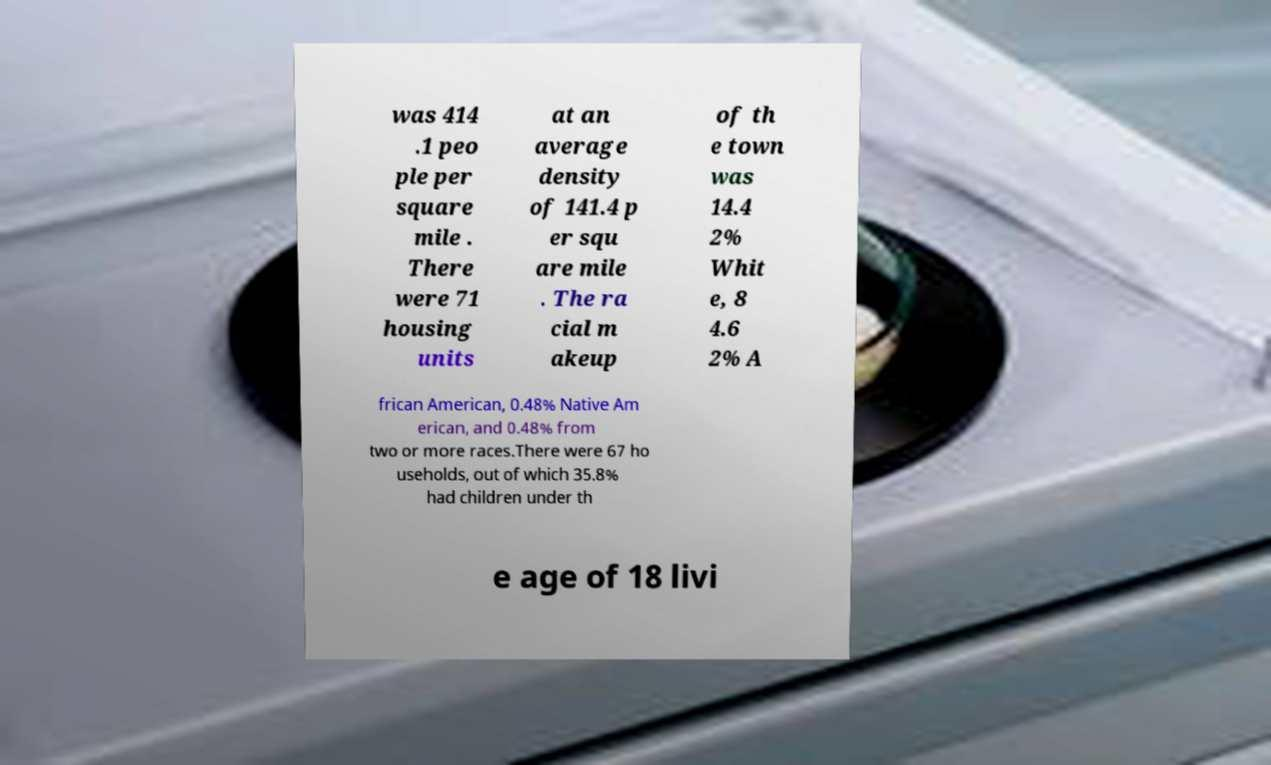What messages or text are displayed in this image? I need them in a readable, typed format. was 414 .1 peo ple per square mile . There were 71 housing units at an average density of 141.4 p er squ are mile . The ra cial m akeup of th e town was 14.4 2% Whit e, 8 4.6 2% A frican American, 0.48% Native Am erican, and 0.48% from two or more races.There were 67 ho useholds, out of which 35.8% had children under th e age of 18 livi 